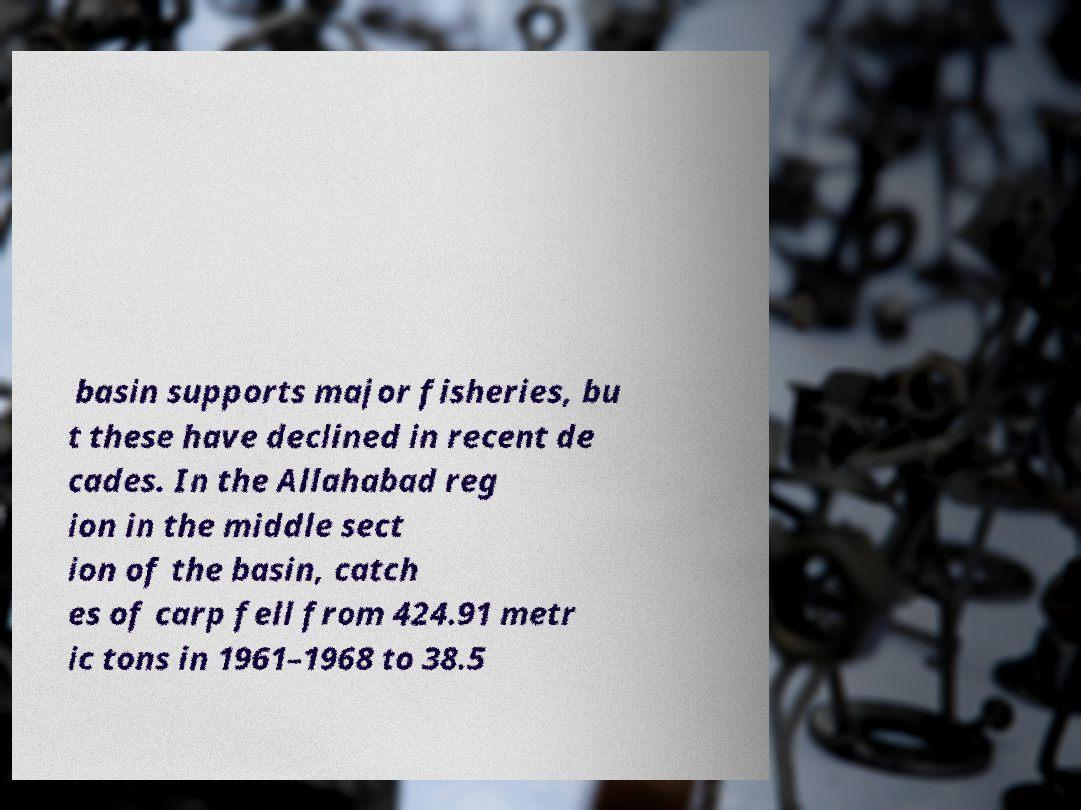Can you accurately transcribe the text from the provided image for me? basin supports major fisheries, bu t these have declined in recent de cades. In the Allahabad reg ion in the middle sect ion of the basin, catch es of carp fell from 424.91 metr ic tons in 1961–1968 to 38.5 